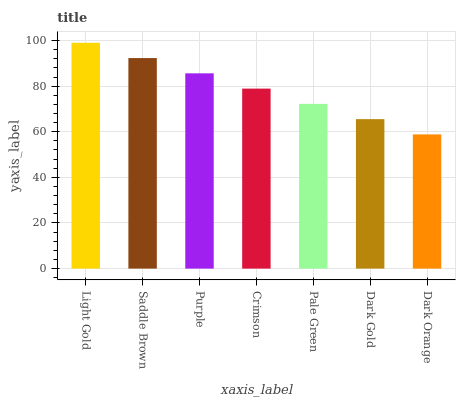Is Dark Orange the minimum?
Answer yes or no. Yes. Is Light Gold the maximum?
Answer yes or no. Yes. Is Saddle Brown the minimum?
Answer yes or no. No. Is Saddle Brown the maximum?
Answer yes or no. No. Is Light Gold greater than Saddle Brown?
Answer yes or no. Yes. Is Saddle Brown less than Light Gold?
Answer yes or no. Yes. Is Saddle Brown greater than Light Gold?
Answer yes or no. No. Is Light Gold less than Saddle Brown?
Answer yes or no. No. Is Crimson the high median?
Answer yes or no. Yes. Is Crimson the low median?
Answer yes or no. Yes. Is Saddle Brown the high median?
Answer yes or no. No. Is Dark Gold the low median?
Answer yes or no. No. 